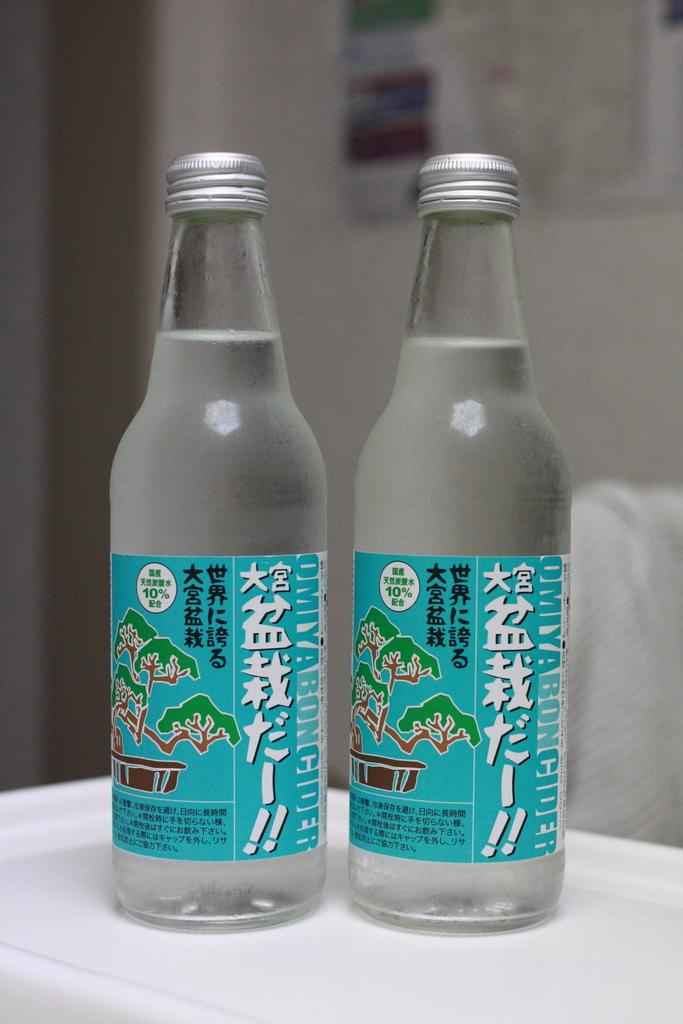What is the number percentage listed on the bottles?
Your response must be concise. 10. 